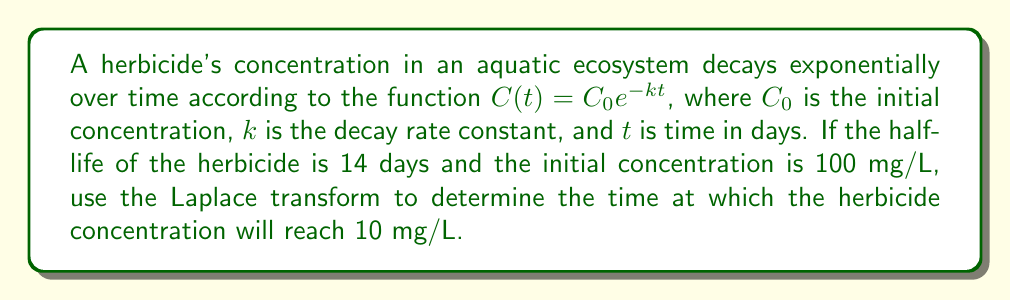Can you solve this math problem? To solve this problem, we'll follow these steps:

1) First, we need to determine the decay rate constant $k$ using the given half-life:

   $T_{1/2} = \frac{\ln(2)}{k}$
   $14 = \frac{\ln(2)}{k}$
   $k = \frac{\ln(2)}{14} \approx 0.0495$ day$^{-1}$

2) Now, we can write our concentration function:

   $C(t) = 100e^{-0.0495t}$

3) We want to find $t$ when $C(t) = 10$ mg/L. Let's set up the equation:

   $10 = 100e^{-0.0495t}$

4) To solve this using Laplace transforms, let's rearrange it to:

   $100e^{-0.0495t} - 10 = 0$

5) Let $F(t) = 100e^{-0.0495t} - 10$. We want to find $t$ when $F(t) = 0$.

6) Take the Laplace transform of both sides:

   $\mathcal{L}\{F(t)\} = \mathcal{L}\{100e^{-0.0495t} - 10\} = 0$

7) Using Laplace transform properties:

   $\frac{100}{s+0.0495} - \frac{10}{s} = 0$

8) Multiply both sides by $s(s+0.0495)$:

   $100s - 10(s+0.0495) = 0$

9) Expand:

   $100s - 10s - 0.495 = 0$
   $90s - 0.495 = 0$

10) Solve for $s$:

    $s = \frac{0.495}{90} = 0.0055$

11) The Laplace transform of a unit step function $u(t-a)$ is $\frac{e^{-as}}{s}$. Therefore, our solution in the time domain is:

    $t = -\frac{\ln(0.0055)}{0.0495} \approx 46.57$ days
Answer: The herbicide concentration will reach 10 mg/L after approximately 46.57 days. 